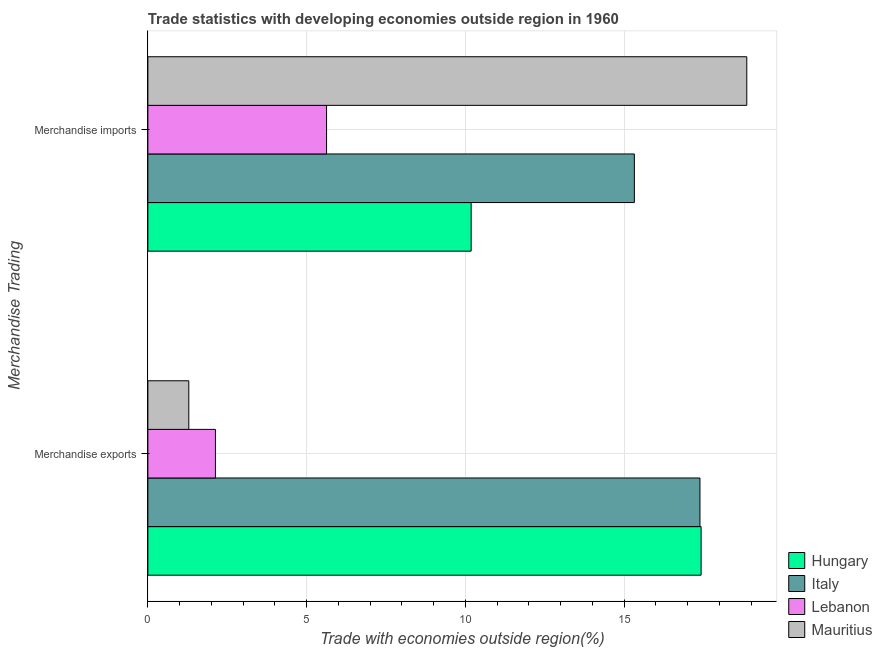Are the number of bars on each tick of the Y-axis equal?
Keep it short and to the point. Yes. What is the label of the 2nd group of bars from the top?
Provide a succinct answer. Merchandise exports. What is the merchandise imports in Mauritius?
Provide a short and direct response. 18.86. Across all countries, what is the maximum merchandise exports?
Your response must be concise. 17.42. Across all countries, what is the minimum merchandise exports?
Provide a short and direct response. 1.29. In which country was the merchandise imports maximum?
Make the answer very short. Mauritius. In which country was the merchandise imports minimum?
Provide a short and direct response. Lebanon. What is the total merchandise exports in the graph?
Offer a very short reply. 38.22. What is the difference between the merchandise imports in Lebanon and that in Mauritius?
Make the answer very short. -13.23. What is the difference between the merchandise imports in Mauritius and the merchandise exports in Lebanon?
Keep it short and to the point. 16.73. What is the average merchandise exports per country?
Ensure brevity in your answer.  9.56. What is the difference between the merchandise imports and merchandise exports in Italy?
Offer a terse response. -2.07. In how many countries, is the merchandise imports greater than 9 %?
Your response must be concise. 3. What is the ratio of the merchandise exports in Hungary to that in Mauritius?
Provide a succinct answer. 13.52. What does the 2nd bar from the top in Merchandise imports represents?
Your answer should be compact. Lebanon. What does the 1st bar from the bottom in Merchandise exports represents?
Your answer should be very brief. Hungary. How many bars are there?
Your answer should be very brief. 8. How many countries are there in the graph?
Make the answer very short. 4. What is the difference between two consecutive major ticks on the X-axis?
Give a very brief answer. 5. How many legend labels are there?
Your answer should be very brief. 4. What is the title of the graph?
Offer a very short reply. Trade statistics with developing economies outside region in 1960. Does "Lower middle income" appear as one of the legend labels in the graph?
Keep it short and to the point. No. What is the label or title of the X-axis?
Make the answer very short. Trade with economies outside region(%). What is the label or title of the Y-axis?
Provide a short and direct response. Merchandise Trading. What is the Trade with economies outside region(%) in Hungary in Merchandise exports?
Your response must be concise. 17.42. What is the Trade with economies outside region(%) in Italy in Merchandise exports?
Your answer should be very brief. 17.38. What is the Trade with economies outside region(%) in Lebanon in Merchandise exports?
Your answer should be compact. 2.13. What is the Trade with economies outside region(%) of Mauritius in Merchandise exports?
Offer a terse response. 1.29. What is the Trade with economies outside region(%) in Hungary in Merchandise imports?
Keep it short and to the point. 10.18. What is the Trade with economies outside region(%) of Italy in Merchandise imports?
Provide a short and direct response. 15.32. What is the Trade with economies outside region(%) in Lebanon in Merchandise imports?
Provide a short and direct response. 5.63. What is the Trade with economies outside region(%) in Mauritius in Merchandise imports?
Keep it short and to the point. 18.86. Across all Merchandise Trading, what is the maximum Trade with economies outside region(%) of Hungary?
Provide a short and direct response. 17.42. Across all Merchandise Trading, what is the maximum Trade with economies outside region(%) of Italy?
Keep it short and to the point. 17.38. Across all Merchandise Trading, what is the maximum Trade with economies outside region(%) of Lebanon?
Keep it short and to the point. 5.63. Across all Merchandise Trading, what is the maximum Trade with economies outside region(%) of Mauritius?
Your answer should be compact. 18.86. Across all Merchandise Trading, what is the minimum Trade with economies outside region(%) of Hungary?
Ensure brevity in your answer.  10.18. Across all Merchandise Trading, what is the minimum Trade with economies outside region(%) in Italy?
Give a very brief answer. 15.32. Across all Merchandise Trading, what is the minimum Trade with economies outside region(%) in Lebanon?
Your answer should be very brief. 2.13. Across all Merchandise Trading, what is the minimum Trade with economies outside region(%) of Mauritius?
Keep it short and to the point. 1.29. What is the total Trade with economies outside region(%) of Hungary in the graph?
Make the answer very short. 27.6. What is the total Trade with economies outside region(%) in Italy in the graph?
Make the answer very short. 32.7. What is the total Trade with economies outside region(%) of Lebanon in the graph?
Keep it short and to the point. 7.75. What is the total Trade with economies outside region(%) in Mauritius in the graph?
Offer a terse response. 20.15. What is the difference between the Trade with economies outside region(%) in Hungary in Merchandise exports and that in Merchandise imports?
Your answer should be very brief. 7.24. What is the difference between the Trade with economies outside region(%) of Italy in Merchandise exports and that in Merchandise imports?
Ensure brevity in your answer.  2.07. What is the difference between the Trade with economies outside region(%) of Lebanon in Merchandise exports and that in Merchandise imports?
Provide a short and direct response. -3.5. What is the difference between the Trade with economies outside region(%) in Mauritius in Merchandise exports and that in Merchandise imports?
Keep it short and to the point. -17.57. What is the difference between the Trade with economies outside region(%) of Hungary in Merchandise exports and the Trade with economies outside region(%) of Italy in Merchandise imports?
Your answer should be very brief. 2.1. What is the difference between the Trade with economies outside region(%) in Hungary in Merchandise exports and the Trade with economies outside region(%) in Lebanon in Merchandise imports?
Provide a succinct answer. 11.79. What is the difference between the Trade with economies outside region(%) of Hungary in Merchandise exports and the Trade with economies outside region(%) of Mauritius in Merchandise imports?
Offer a very short reply. -1.44. What is the difference between the Trade with economies outside region(%) in Italy in Merchandise exports and the Trade with economies outside region(%) in Lebanon in Merchandise imports?
Provide a succinct answer. 11.76. What is the difference between the Trade with economies outside region(%) in Italy in Merchandise exports and the Trade with economies outside region(%) in Mauritius in Merchandise imports?
Offer a terse response. -1.47. What is the difference between the Trade with economies outside region(%) of Lebanon in Merchandise exports and the Trade with economies outside region(%) of Mauritius in Merchandise imports?
Your response must be concise. -16.73. What is the average Trade with economies outside region(%) of Hungary per Merchandise Trading?
Ensure brevity in your answer.  13.8. What is the average Trade with economies outside region(%) of Italy per Merchandise Trading?
Your answer should be very brief. 16.35. What is the average Trade with economies outside region(%) of Lebanon per Merchandise Trading?
Your response must be concise. 3.88. What is the average Trade with economies outside region(%) of Mauritius per Merchandise Trading?
Offer a very short reply. 10.07. What is the difference between the Trade with economies outside region(%) of Hungary and Trade with economies outside region(%) of Italy in Merchandise exports?
Ensure brevity in your answer.  0.04. What is the difference between the Trade with economies outside region(%) in Hungary and Trade with economies outside region(%) in Lebanon in Merchandise exports?
Keep it short and to the point. 15.29. What is the difference between the Trade with economies outside region(%) in Hungary and Trade with economies outside region(%) in Mauritius in Merchandise exports?
Ensure brevity in your answer.  16.13. What is the difference between the Trade with economies outside region(%) in Italy and Trade with economies outside region(%) in Lebanon in Merchandise exports?
Keep it short and to the point. 15.26. What is the difference between the Trade with economies outside region(%) of Italy and Trade with economies outside region(%) of Mauritius in Merchandise exports?
Keep it short and to the point. 16.1. What is the difference between the Trade with economies outside region(%) in Lebanon and Trade with economies outside region(%) in Mauritius in Merchandise exports?
Offer a terse response. 0.84. What is the difference between the Trade with economies outside region(%) in Hungary and Trade with economies outside region(%) in Italy in Merchandise imports?
Offer a terse response. -5.14. What is the difference between the Trade with economies outside region(%) in Hungary and Trade with economies outside region(%) in Lebanon in Merchandise imports?
Offer a terse response. 4.55. What is the difference between the Trade with economies outside region(%) in Hungary and Trade with economies outside region(%) in Mauritius in Merchandise imports?
Keep it short and to the point. -8.68. What is the difference between the Trade with economies outside region(%) in Italy and Trade with economies outside region(%) in Lebanon in Merchandise imports?
Your answer should be very brief. 9.69. What is the difference between the Trade with economies outside region(%) of Italy and Trade with economies outside region(%) of Mauritius in Merchandise imports?
Give a very brief answer. -3.54. What is the difference between the Trade with economies outside region(%) of Lebanon and Trade with economies outside region(%) of Mauritius in Merchandise imports?
Offer a terse response. -13.23. What is the ratio of the Trade with economies outside region(%) in Hungary in Merchandise exports to that in Merchandise imports?
Your response must be concise. 1.71. What is the ratio of the Trade with economies outside region(%) of Italy in Merchandise exports to that in Merchandise imports?
Your response must be concise. 1.13. What is the ratio of the Trade with economies outside region(%) in Lebanon in Merchandise exports to that in Merchandise imports?
Offer a very short reply. 0.38. What is the ratio of the Trade with economies outside region(%) in Mauritius in Merchandise exports to that in Merchandise imports?
Offer a terse response. 0.07. What is the difference between the highest and the second highest Trade with economies outside region(%) in Hungary?
Provide a succinct answer. 7.24. What is the difference between the highest and the second highest Trade with economies outside region(%) of Italy?
Provide a succinct answer. 2.07. What is the difference between the highest and the second highest Trade with economies outside region(%) of Lebanon?
Provide a succinct answer. 3.5. What is the difference between the highest and the second highest Trade with economies outside region(%) in Mauritius?
Keep it short and to the point. 17.57. What is the difference between the highest and the lowest Trade with economies outside region(%) of Hungary?
Make the answer very short. 7.24. What is the difference between the highest and the lowest Trade with economies outside region(%) of Italy?
Offer a very short reply. 2.07. What is the difference between the highest and the lowest Trade with economies outside region(%) of Lebanon?
Make the answer very short. 3.5. What is the difference between the highest and the lowest Trade with economies outside region(%) in Mauritius?
Provide a short and direct response. 17.57. 